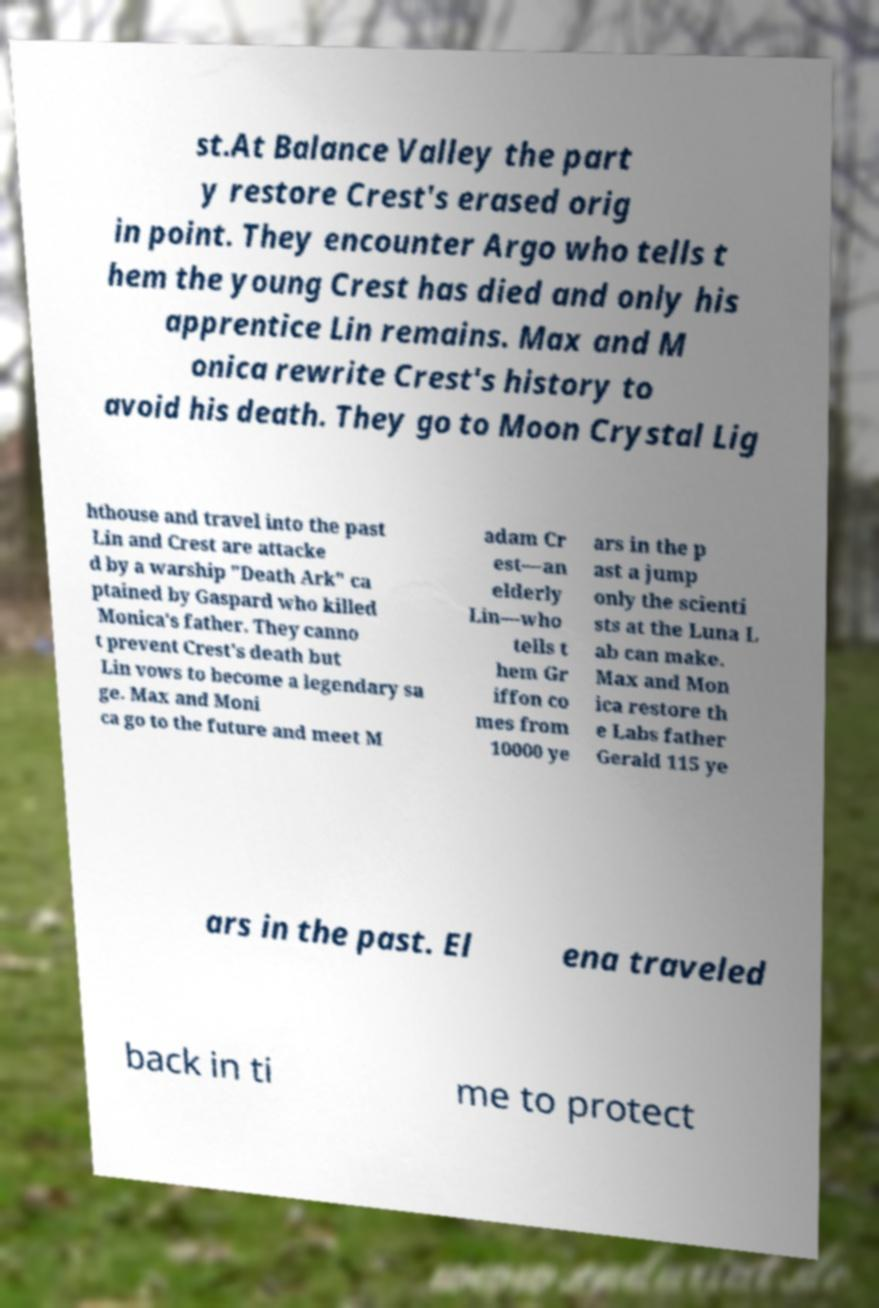For documentation purposes, I need the text within this image transcribed. Could you provide that? st.At Balance Valley the part y restore Crest's erased orig in point. They encounter Argo who tells t hem the young Crest has died and only his apprentice Lin remains. Max and M onica rewrite Crest's history to avoid his death. They go to Moon Crystal Lig hthouse and travel into the past Lin and Crest are attacke d by a warship "Death Ark" ca ptained by Gaspard who killed Monica's father. They canno t prevent Crest's death but Lin vows to become a legendary sa ge. Max and Moni ca go to the future and meet M adam Cr est—an elderly Lin—who tells t hem Gr iffon co mes from 10000 ye ars in the p ast a jump only the scienti sts at the Luna L ab can make. Max and Mon ica restore th e Labs father Gerald 115 ye ars in the past. El ena traveled back in ti me to protect 